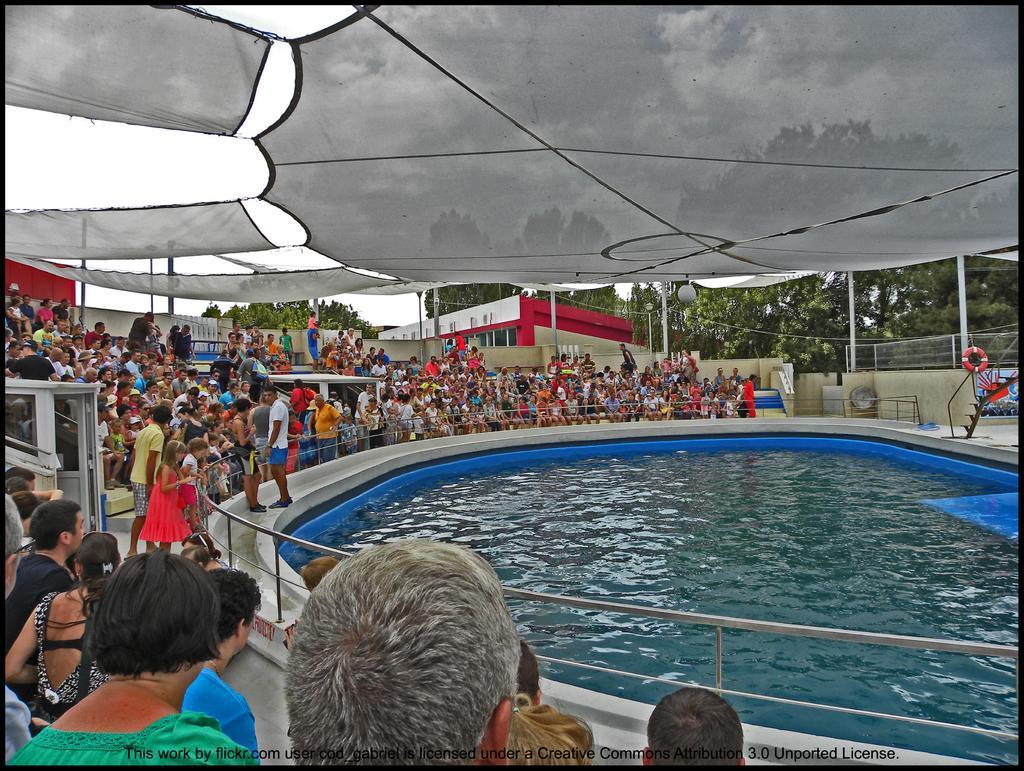Describe this image in one or two sentences. In this picture there is a swimming pool in the center of the image and there are people around it, there is a roof at the top side of the image and there are trees in the background area of the image. 